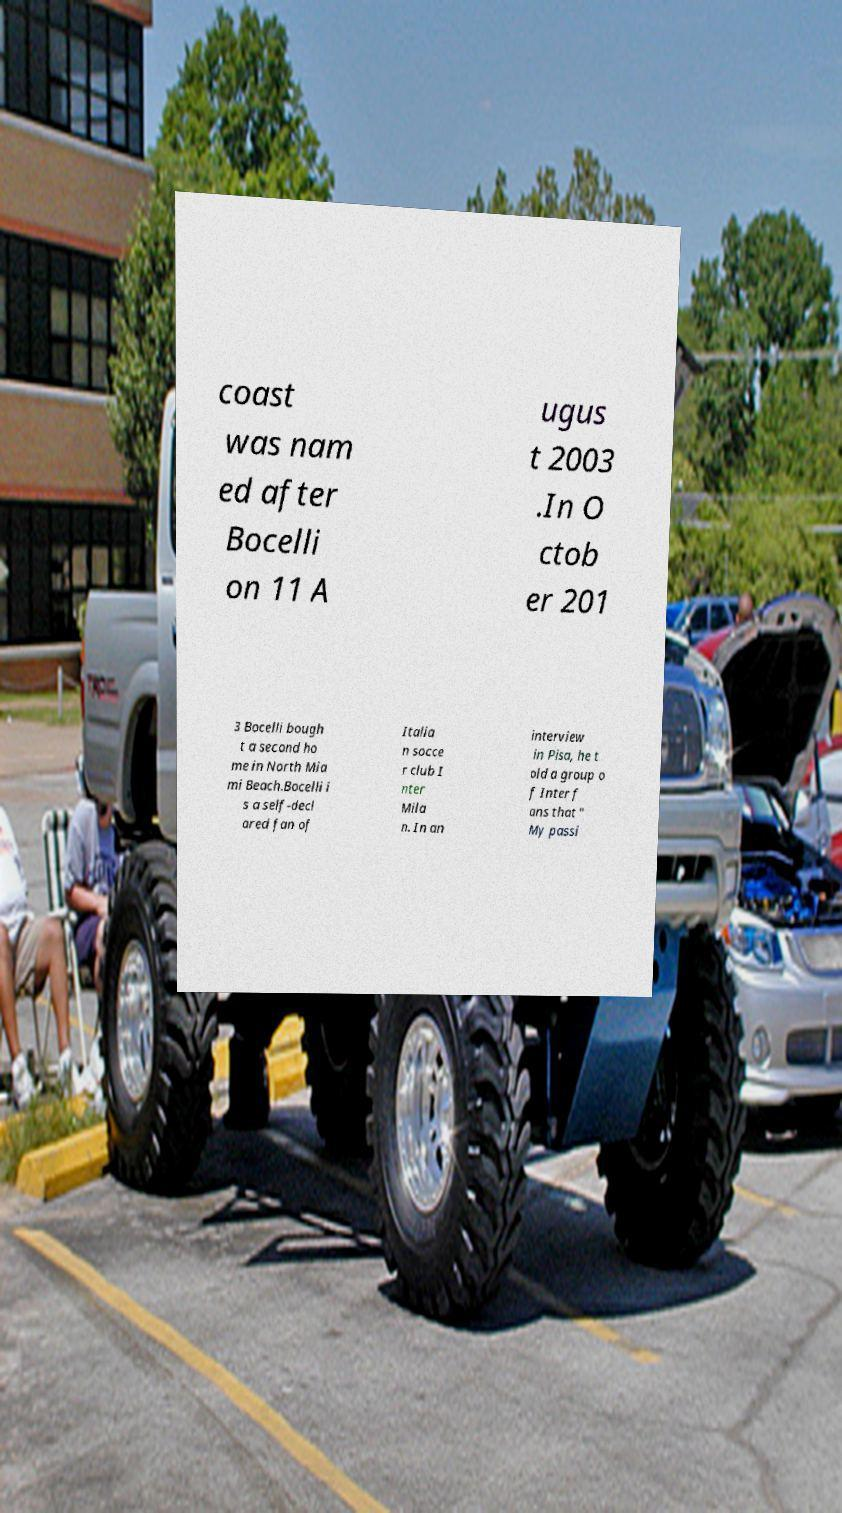For documentation purposes, I need the text within this image transcribed. Could you provide that? coast was nam ed after Bocelli on 11 A ugus t 2003 .In O ctob er 201 3 Bocelli bough t a second ho me in North Mia mi Beach.Bocelli i s a self-decl ared fan of Italia n socce r club I nter Mila n. In an interview in Pisa, he t old a group o f Inter f ans that " My passi 